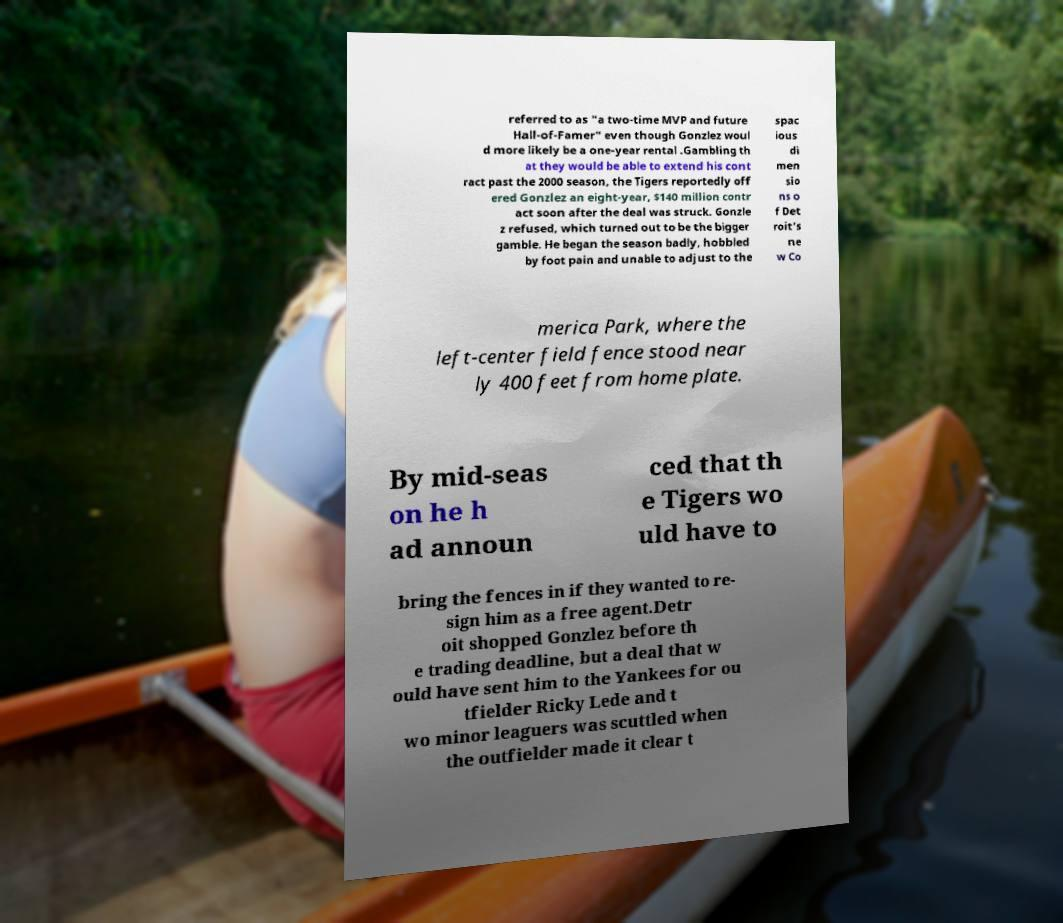For documentation purposes, I need the text within this image transcribed. Could you provide that? referred to as "a two-time MVP and future Hall-of-Famer" even though Gonzlez woul d more likely be a one-year rental .Gambling th at they would be able to extend his cont ract past the 2000 season, the Tigers reportedly off ered Gonzlez an eight-year, $140 million contr act soon after the deal was struck. Gonzle z refused, which turned out to be the bigger gamble. He began the season badly, hobbled by foot pain and unable to adjust to the spac ious di men sio ns o f Det roit's ne w Co merica Park, where the left-center field fence stood near ly 400 feet from home plate. By mid-seas on he h ad announ ced that th e Tigers wo uld have to bring the fences in if they wanted to re- sign him as a free agent.Detr oit shopped Gonzlez before th e trading deadline, but a deal that w ould have sent him to the Yankees for ou tfielder Ricky Lede and t wo minor leaguers was scuttled when the outfielder made it clear t 